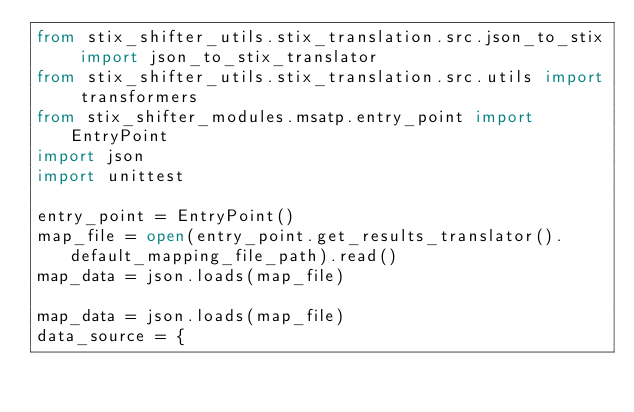<code> <loc_0><loc_0><loc_500><loc_500><_Python_>from stix_shifter_utils.stix_translation.src.json_to_stix import json_to_stix_translator
from stix_shifter_utils.stix_translation.src.utils import transformers
from stix_shifter_modules.msatp.entry_point import EntryPoint
import json
import unittest

entry_point = EntryPoint()
map_file = open(entry_point.get_results_translator().default_mapping_file_path).read()
map_data = json.loads(map_file)

map_data = json.loads(map_file)
data_source = {</code> 